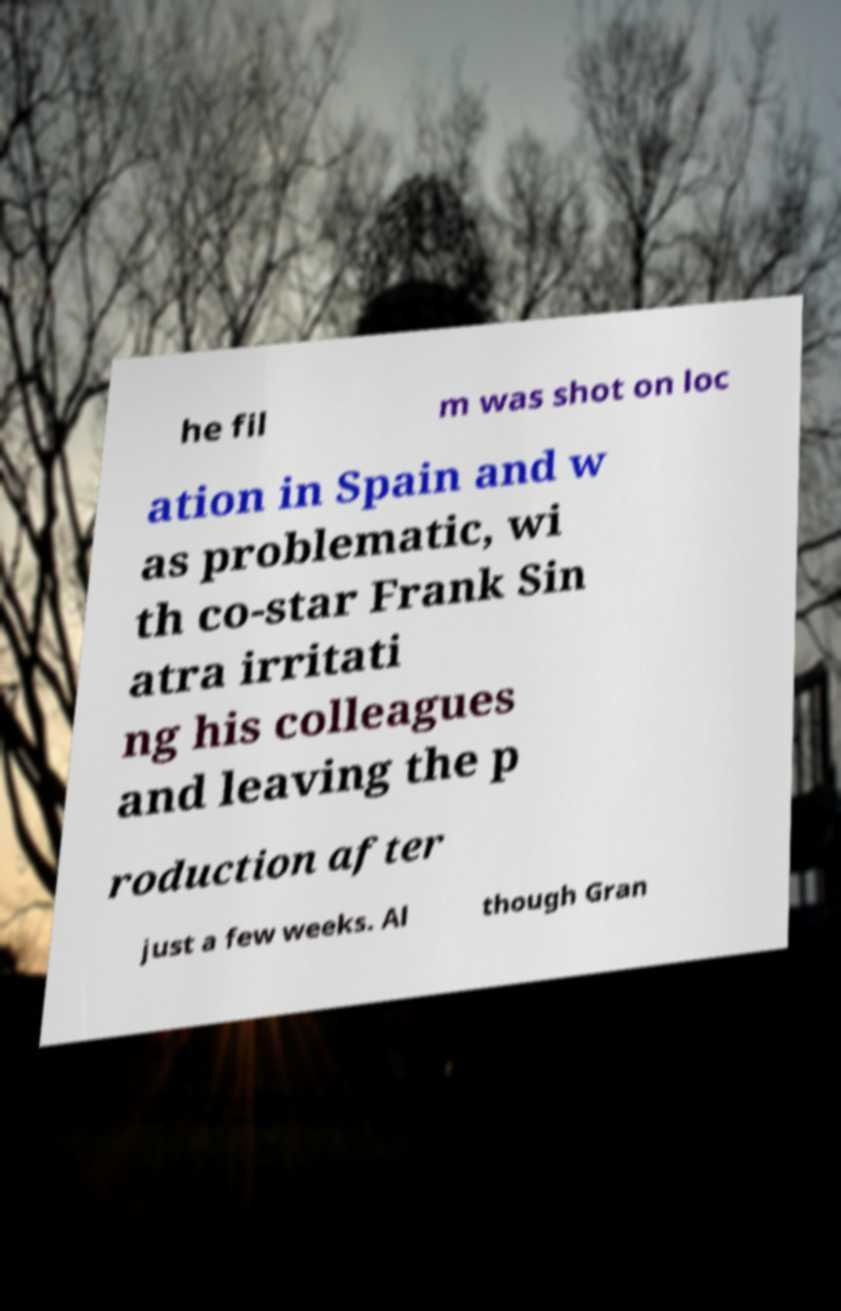What messages or text are displayed in this image? I need them in a readable, typed format. he fil m was shot on loc ation in Spain and w as problematic, wi th co-star Frank Sin atra irritati ng his colleagues and leaving the p roduction after just a few weeks. Al though Gran 